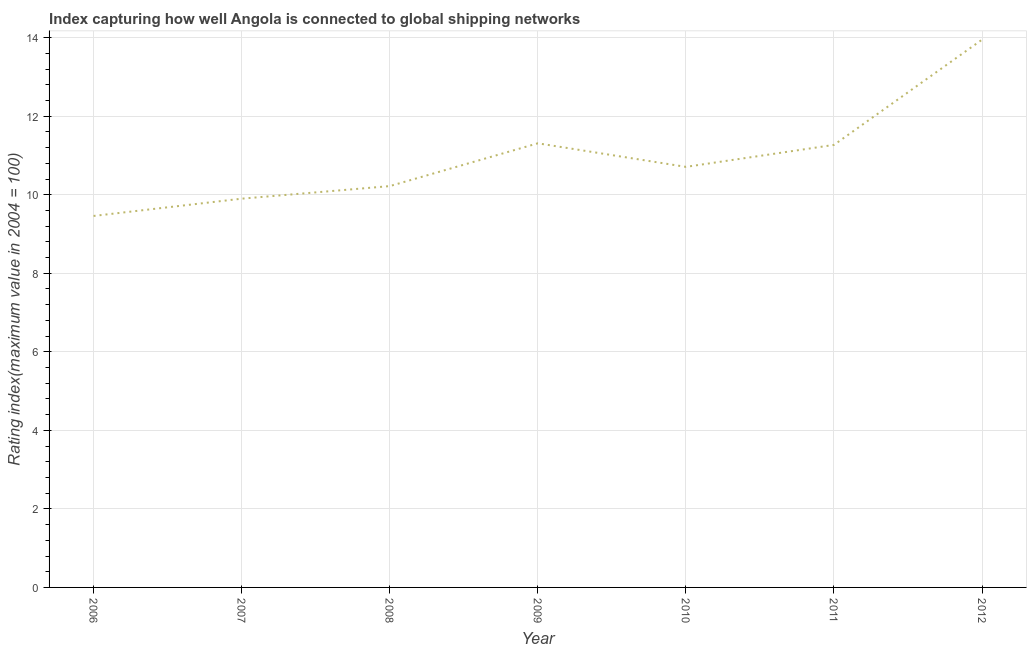Across all years, what is the maximum liner shipping connectivity index?
Your answer should be very brief. 13.95. Across all years, what is the minimum liner shipping connectivity index?
Offer a very short reply. 9.46. What is the sum of the liner shipping connectivity index?
Your response must be concise. 76.82. What is the difference between the liner shipping connectivity index in 2011 and 2012?
Make the answer very short. -2.68. What is the average liner shipping connectivity index per year?
Offer a very short reply. 10.97. What is the median liner shipping connectivity index?
Make the answer very short. 10.71. In how many years, is the liner shipping connectivity index greater than 3.2 ?
Provide a succinct answer. 7. What is the ratio of the liner shipping connectivity index in 2009 to that in 2010?
Your answer should be compact. 1.06. Is the liner shipping connectivity index in 2007 less than that in 2008?
Your answer should be compact. Yes. Is the difference between the liner shipping connectivity index in 2010 and 2011 greater than the difference between any two years?
Offer a very short reply. No. What is the difference between the highest and the second highest liner shipping connectivity index?
Your answer should be compact. 2.64. What is the difference between the highest and the lowest liner shipping connectivity index?
Give a very brief answer. 4.49. Does the liner shipping connectivity index monotonically increase over the years?
Offer a terse response. No. How many years are there in the graph?
Give a very brief answer. 7. Are the values on the major ticks of Y-axis written in scientific E-notation?
Offer a terse response. No. Does the graph contain any zero values?
Your answer should be compact. No. What is the title of the graph?
Provide a short and direct response. Index capturing how well Angola is connected to global shipping networks. What is the label or title of the X-axis?
Keep it short and to the point. Year. What is the label or title of the Y-axis?
Provide a succinct answer. Rating index(maximum value in 2004 = 100). What is the Rating index(maximum value in 2004 = 100) of 2006?
Your answer should be compact. 9.46. What is the Rating index(maximum value in 2004 = 100) in 2008?
Your answer should be very brief. 10.22. What is the Rating index(maximum value in 2004 = 100) in 2009?
Provide a short and direct response. 11.31. What is the Rating index(maximum value in 2004 = 100) in 2010?
Your answer should be compact. 10.71. What is the Rating index(maximum value in 2004 = 100) in 2011?
Your answer should be compact. 11.27. What is the Rating index(maximum value in 2004 = 100) in 2012?
Your response must be concise. 13.95. What is the difference between the Rating index(maximum value in 2004 = 100) in 2006 and 2007?
Ensure brevity in your answer.  -0.44. What is the difference between the Rating index(maximum value in 2004 = 100) in 2006 and 2008?
Provide a succinct answer. -0.76. What is the difference between the Rating index(maximum value in 2004 = 100) in 2006 and 2009?
Keep it short and to the point. -1.85. What is the difference between the Rating index(maximum value in 2004 = 100) in 2006 and 2010?
Provide a short and direct response. -1.25. What is the difference between the Rating index(maximum value in 2004 = 100) in 2006 and 2011?
Your response must be concise. -1.81. What is the difference between the Rating index(maximum value in 2004 = 100) in 2006 and 2012?
Your answer should be very brief. -4.49. What is the difference between the Rating index(maximum value in 2004 = 100) in 2007 and 2008?
Provide a short and direct response. -0.32. What is the difference between the Rating index(maximum value in 2004 = 100) in 2007 and 2009?
Provide a short and direct response. -1.41. What is the difference between the Rating index(maximum value in 2004 = 100) in 2007 and 2010?
Provide a succinct answer. -0.81. What is the difference between the Rating index(maximum value in 2004 = 100) in 2007 and 2011?
Offer a very short reply. -1.37. What is the difference between the Rating index(maximum value in 2004 = 100) in 2007 and 2012?
Make the answer very short. -4.05. What is the difference between the Rating index(maximum value in 2004 = 100) in 2008 and 2009?
Keep it short and to the point. -1.09. What is the difference between the Rating index(maximum value in 2004 = 100) in 2008 and 2010?
Offer a terse response. -0.49. What is the difference between the Rating index(maximum value in 2004 = 100) in 2008 and 2011?
Ensure brevity in your answer.  -1.05. What is the difference between the Rating index(maximum value in 2004 = 100) in 2008 and 2012?
Give a very brief answer. -3.73. What is the difference between the Rating index(maximum value in 2004 = 100) in 2009 and 2010?
Offer a very short reply. 0.6. What is the difference between the Rating index(maximum value in 2004 = 100) in 2009 and 2011?
Offer a very short reply. 0.04. What is the difference between the Rating index(maximum value in 2004 = 100) in 2009 and 2012?
Offer a very short reply. -2.64. What is the difference between the Rating index(maximum value in 2004 = 100) in 2010 and 2011?
Your response must be concise. -0.56. What is the difference between the Rating index(maximum value in 2004 = 100) in 2010 and 2012?
Offer a very short reply. -3.24. What is the difference between the Rating index(maximum value in 2004 = 100) in 2011 and 2012?
Keep it short and to the point. -2.68. What is the ratio of the Rating index(maximum value in 2004 = 100) in 2006 to that in 2007?
Provide a succinct answer. 0.96. What is the ratio of the Rating index(maximum value in 2004 = 100) in 2006 to that in 2008?
Ensure brevity in your answer.  0.93. What is the ratio of the Rating index(maximum value in 2004 = 100) in 2006 to that in 2009?
Provide a short and direct response. 0.84. What is the ratio of the Rating index(maximum value in 2004 = 100) in 2006 to that in 2010?
Provide a succinct answer. 0.88. What is the ratio of the Rating index(maximum value in 2004 = 100) in 2006 to that in 2011?
Provide a succinct answer. 0.84. What is the ratio of the Rating index(maximum value in 2004 = 100) in 2006 to that in 2012?
Your answer should be very brief. 0.68. What is the ratio of the Rating index(maximum value in 2004 = 100) in 2007 to that in 2008?
Provide a succinct answer. 0.97. What is the ratio of the Rating index(maximum value in 2004 = 100) in 2007 to that in 2009?
Provide a succinct answer. 0.88. What is the ratio of the Rating index(maximum value in 2004 = 100) in 2007 to that in 2010?
Ensure brevity in your answer.  0.92. What is the ratio of the Rating index(maximum value in 2004 = 100) in 2007 to that in 2011?
Provide a succinct answer. 0.88. What is the ratio of the Rating index(maximum value in 2004 = 100) in 2007 to that in 2012?
Your response must be concise. 0.71. What is the ratio of the Rating index(maximum value in 2004 = 100) in 2008 to that in 2009?
Give a very brief answer. 0.9. What is the ratio of the Rating index(maximum value in 2004 = 100) in 2008 to that in 2010?
Your answer should be very brief. 0.95. What is the ratio of the Rating index(maximum value in 2004 = 100) in 2008 to that in 2011?
Your response must be concise. 0.91. What is the ratio of the Rating index(maximum value in 2004 = 100) in 2008 to that in 2012?
Your response must be concise. 0.73. What is the ratio of the Rating index(maximum value in 2004 = 100) in 2009 to that in 2010?
Provide a short and direct response. 1.06. What is the ratio of the Rating index(maximum value in 2004 = 100) in 2009 to that in 2011?
Your response must be concise. 1. What is the ratio of the Rating index(maximum value in 2004 = 100) in 2009 to that in 2012?
Make the answer very short. 0.81. What is the ratio of the Rating index(maximum value in 2004 = 100) in 2010 to that in 2011?
Give a very brief answer. 0.95. What is the ratio of the Rating index(maximum value in 2004 = 100) in 2010 to that in 2012?
Give a very brief answer. 0.77. What is the ratio of the Rating index(maximum value in 2004 = 100) in 2011 to that in 2012?
Your answer should be very brief. 0.81. 